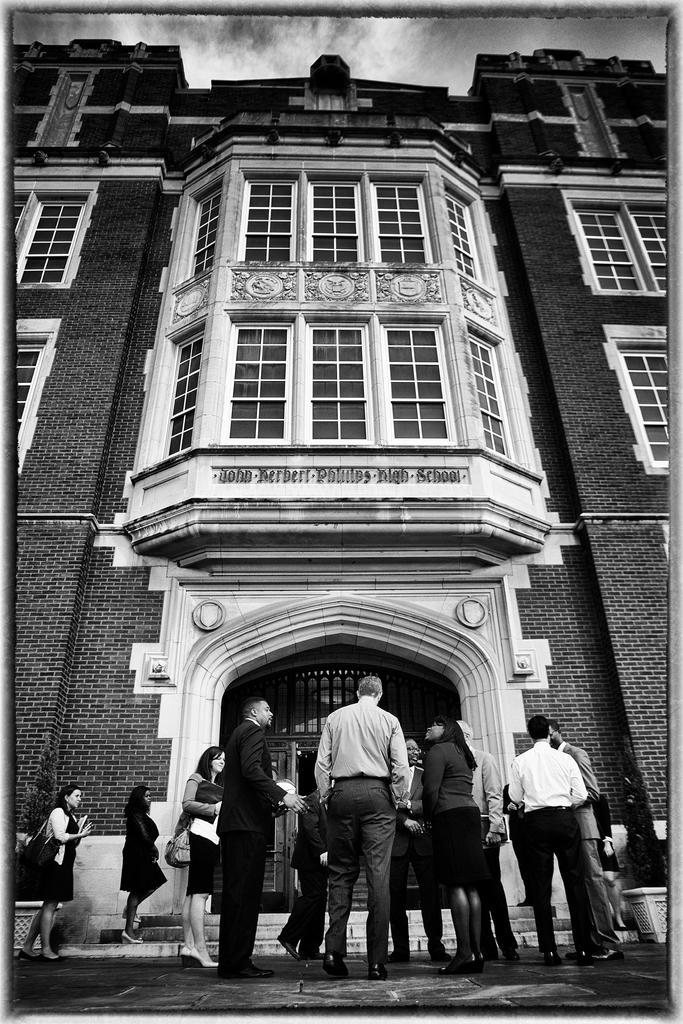Describe this image in one or two sentences. This is a black and white image, where there are persons standing on the side path. In the background, there is a building. On the top, there is the sky and the cloud. 